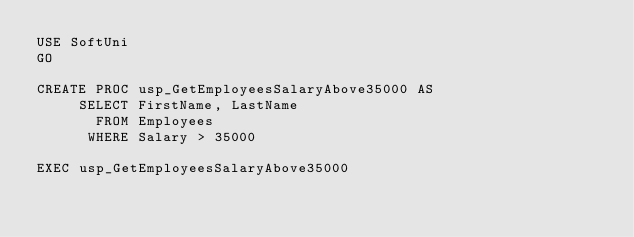Convert code to text. <code><loc_0><loc_0><loc_500><loc_500><_SQL_>USE SoftUni
GO

CREATE PROC usp_GetEmployeesSalaryAbove35000 AS
	 SELECT FirstName, LastName
	   FROM Employees
	  WHERE Salary > 35000

EXEC usp_GetEmployeesSalaryAbove35000</code> 